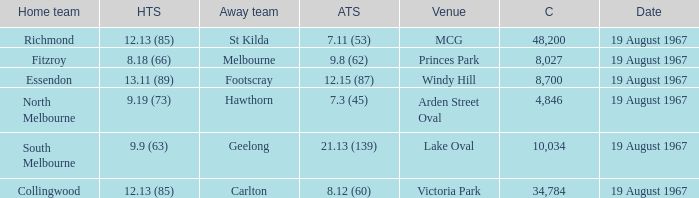Would you mind parsing the complete table? {'header': ['Home team', 'HTS', 'Away team', 'ATS', 'Venue', 'C', 'Date'], 'rows': [['Richmond', '12.13 (85)', 'St Kilda', '7.11 (53)', 'MCG', '48,200', '19 August 1967'], ['Fitzroy', '8.18 (66)', 'Melbourne', '9.8 (62)', 'Princes Park', '8,027', '19 August 1967'], ['Essendon', '13.11 (89)', 'Footscray', '12.15 (87)', 'Windy Hill', '8,700', '19 August 1967'], ['North Melbourne', '9.19 (73)', 'Hawthorn', '7.3 (45)', 'Arden Street Oval', '4,846', '19 August 1967'], ['South Melbourne', '9.9 (63)', 'Geelong', '21.13 (139)', 'Lake Oval', '10,034', '19 August 1967'], ['Collingwood', '12.13 (85)', 'Carlton', '8.12 (60)', 'Victoria Park', '34,784', '19 August 1967']]} When the away team scored 7.11 (53) what venue did they play at? MCG. 